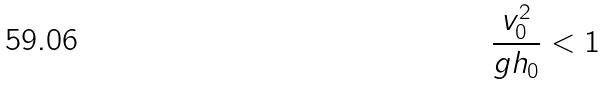<formula> <loc_0><loc_0><loc_500><loc_500>\frac { v _ { 0 } ^ { 2 } } { g h _ { 0 } } < 1</formula> 